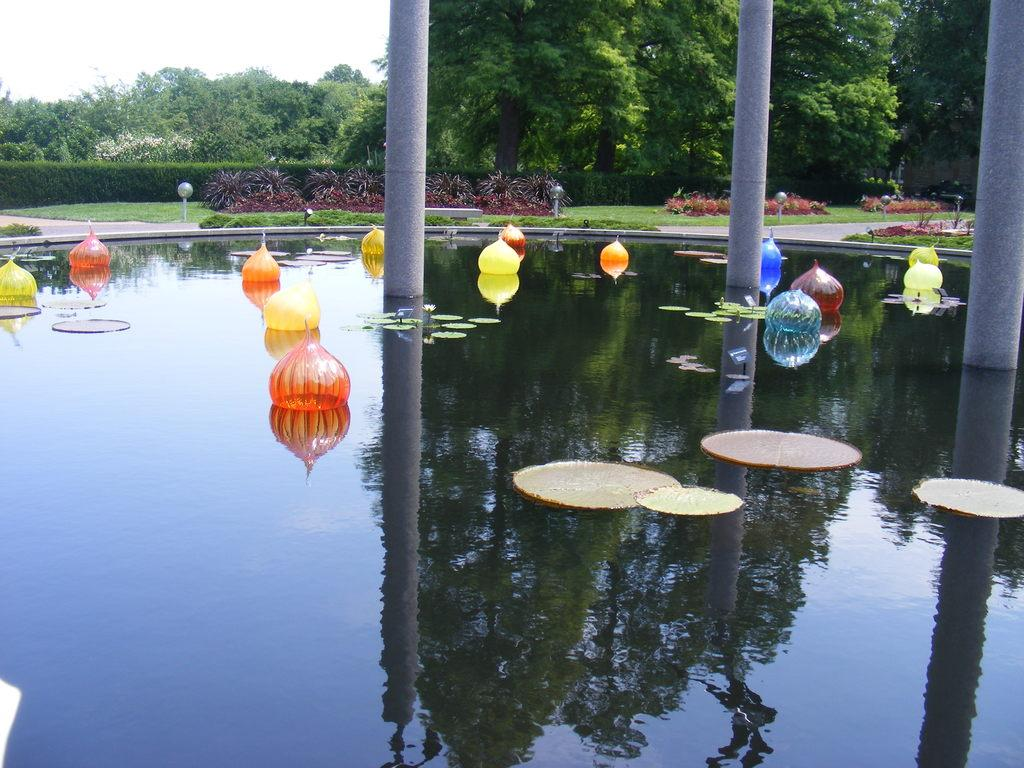What type of decorations can be seen in the image? There are decoration balloons in the image. What is floating on the water in the image? Lotus leaves are floating on the water in the image. What structures can be seen in the background of the image? Poles, shrubs, grass, light poles, and trees are present in the background of the image. What part of the natural environment is visible in the image? The sky is visible in the background of the image. What type of drain is visible in the image? There is no drain present in the image. What type of roof can be seen on the building in the image? There is no building or roof visible in the image. 